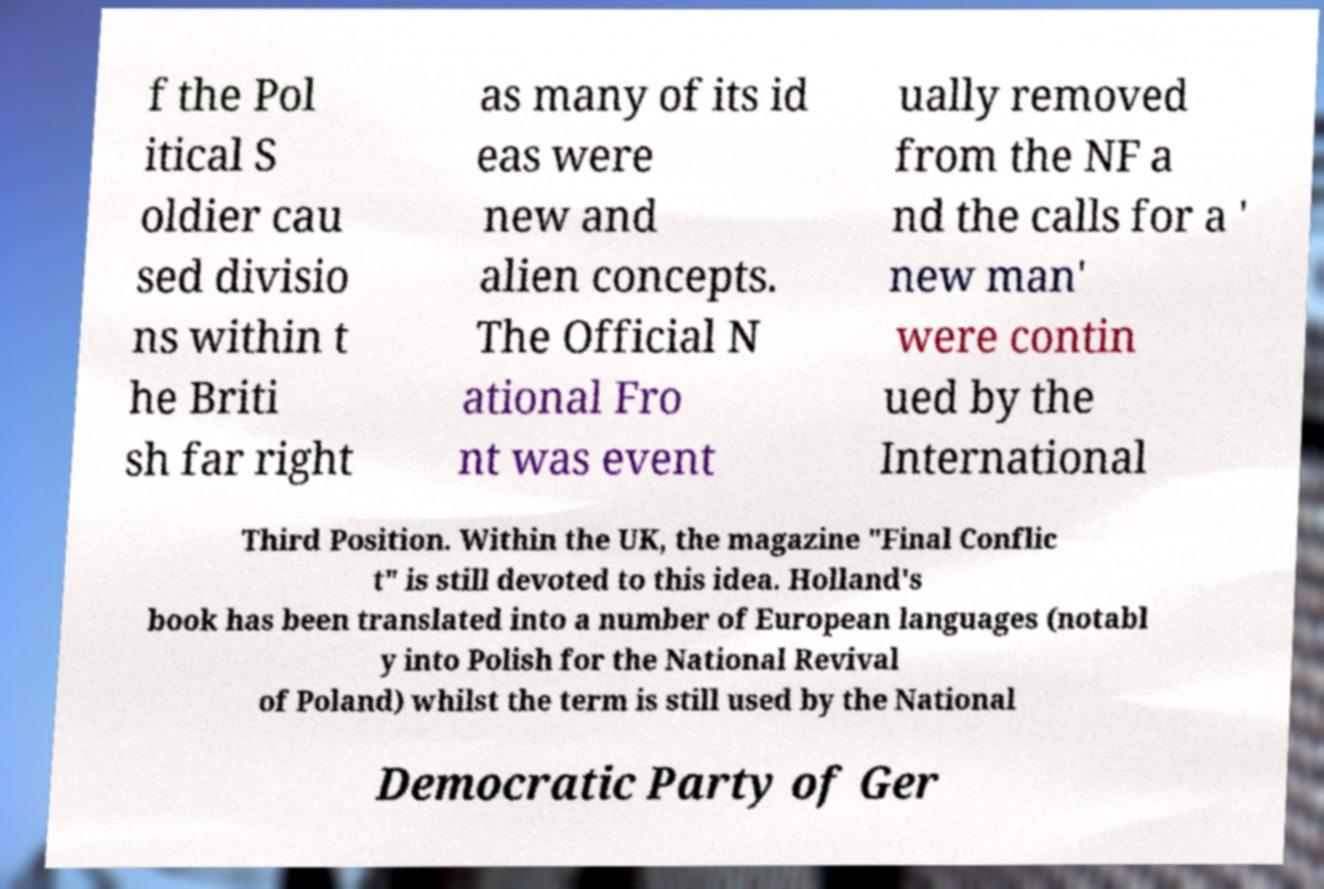Can you accurately transcribe the text from the provided image for me? f the Pol itical S oldier cau sed divisio ns within t he Briti sh far right as many of its id eas were new and alien concepts. The Official N ational Fro nt was event ually removed from the NF a nd the calls for a ' new man' were contin ued by the International Third Position. Within the UK, the magazine "Final Conflic t" is still devoted to this idea. Holland's book has been translated into a number of European languages (notabl y into Polish for the National Revival of Poland) whilst the term is still used by the National Democratic Party of Ger 